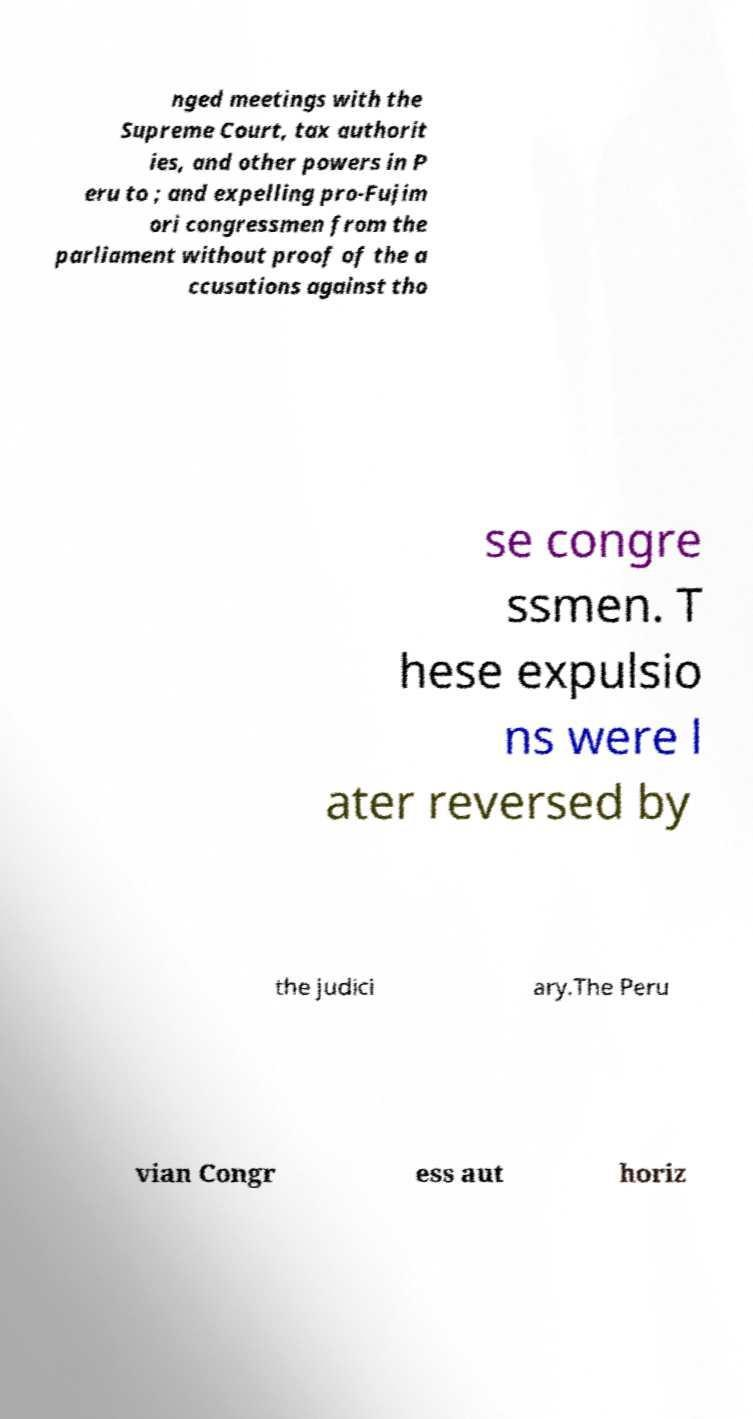Please identify and transcribe the text found in this image. nged meetings with the Supreme Court, tax authorit ies, and other powers in P eru to ; and expelling pro-Fujim ori congressmen from the parliament without proof of the a ccusations against tho se congre ssmen. T hese expulsio ns were l ater reversed by the judici ary.The Peru vian Congr ess aut horiz 